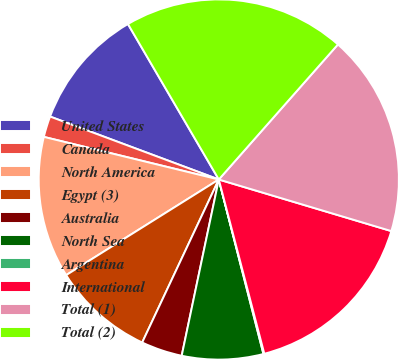Convert chart. <chart><loc_0><loc_0><loc_500><loc_500><pie_chart><fcel>United States<fcel>Canada<fcel>North America<fcel>Egypt (3)<fcel>Australia<fcel>North Sea<fcel>Argentina<fcel>International<fcel>Total (1)<fcel>Total (2)<nl><fcel>10.9%<fcel>1.88%<fcel>12.71%<fcel>9.1%<fcel>3.69%<fcel>7.29%<fcel>0.08%<fcel>16.31%<fcel>18.12%<fcel>19.92%<nl></chart> 